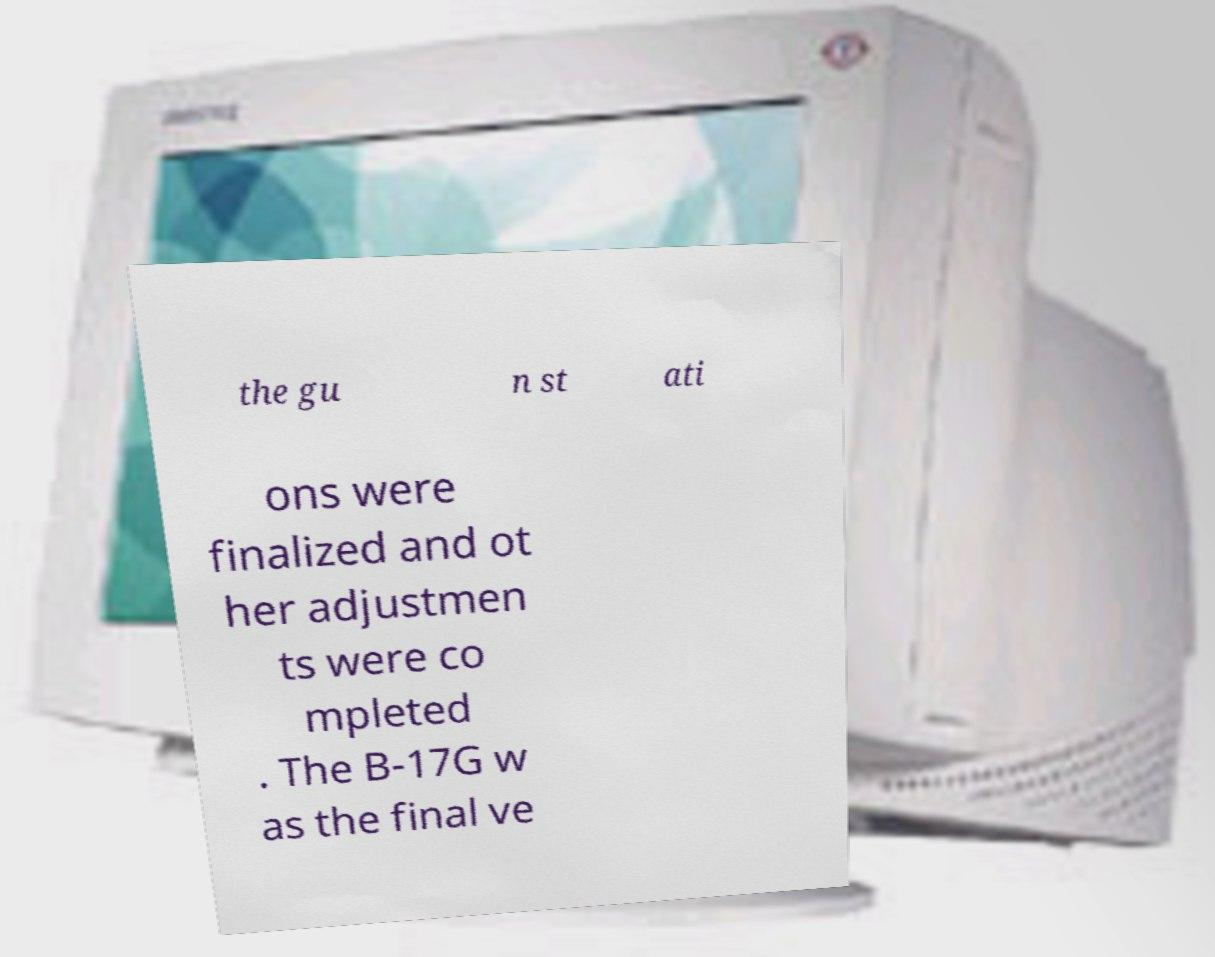Please read and relay the text visible in this image. What does it say? the gu n st ati ons were finalized and ot her adjustmen ts were co mpleted . The B-17G w as the final ve 